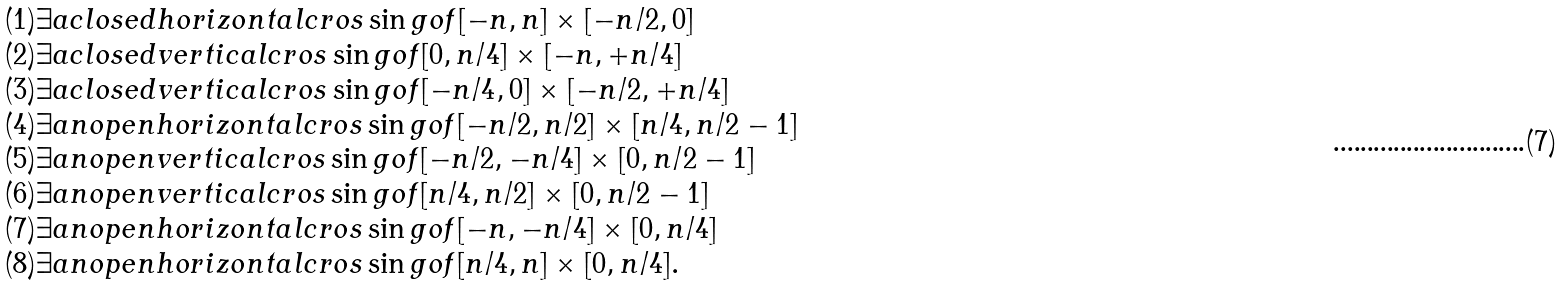Convert formula to latex. <formula><loc_0><loc_0><loc_500><loc_500>\begin{array} { l l } & ( 1 ) \exists a c l o s e d h o r i z o n t a l c r o s \sin g o f [ - n , n ] \times [ - n / 2 , 0 ] \\ & ( 2 ) \exists a c l o s e d v e r t i c a l c r o s \sin g o f [ 0 , n / 4 ] \times [ - n , + n / 4 ] \\ & ( 3 ) \exists a c l o s e d v e r t i c a l c r o s \sin g o f [ - n / 4 , 0 ] \times [ - n / 2 , + n / 4 ] \\ & ( 4 ) \exists a n o p e n h o r i z o n t a l c r o s \sin g o f [ - n / 2 , n / 2 ] \times [ n / 4 , n / 2 - 1 ] \\ & ( 5 ) \exists a n o p e n v e r t i c a l c r o s \sin g o f [ - n / 2 , - n / 4 ] \times [ 0 , n / 2 - 1 ] \\ & ( 6 ) \exists a n o p e n v e r t i c a l c r o s \sin g o f [ n / 4 , n / 2 ] \times [ 0 , n / 2 - 1 ] \\ & ( 7 ) \exists a n o p e n h o r i z o n t a l c r o s \sin g o f [ - n , - n / 4 ] \times [ 0 , n / 4 ] \\ & ( 8 ) \exists a n o p e n h o r i z o n t a l c r o s \sin g o f [ n / 4 , n ] \times [ 0 , n / 4 ] . \end{array}</formula> 